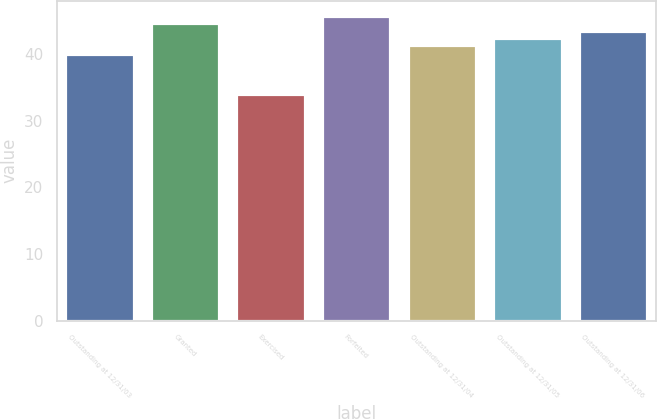Convert chart to OTSL. <chart><loc_0><loc_0><loc_500><loc_500><bar_chart><fcel>Outstanding at 12/31/03<fcel>Granted<fcel>Exercised<fcel>Forfeited<fcel>Outstanding at 12/31/04<fcel>Outstanding at 12/31/05<fcel>Outstanding at 12/31/06<nl><fcel>40.06<fcel>44.63<fcel>34.01<fcel>45.74<fcel>41.3<fcel>42.41<fcel>43.52<nl></chart> 